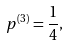<formula> <loc_0><loc_0><loc_500><loc_500>p ^ { ( 3 ) } = \frac { 1 } { 4 } ,</formula> 